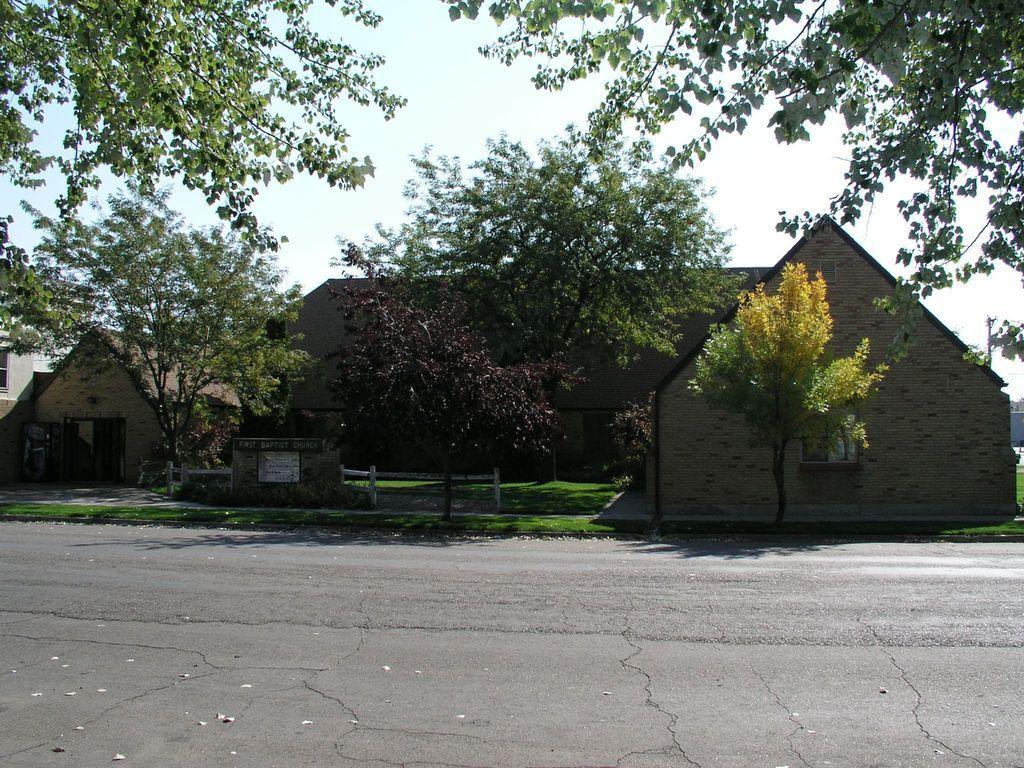Can you describe this image briefly? In the center of the image we can see houses, trees, are there. At the top of the image sky is there. At the bottom of the image road is there. In the middle of the image grass is there. 